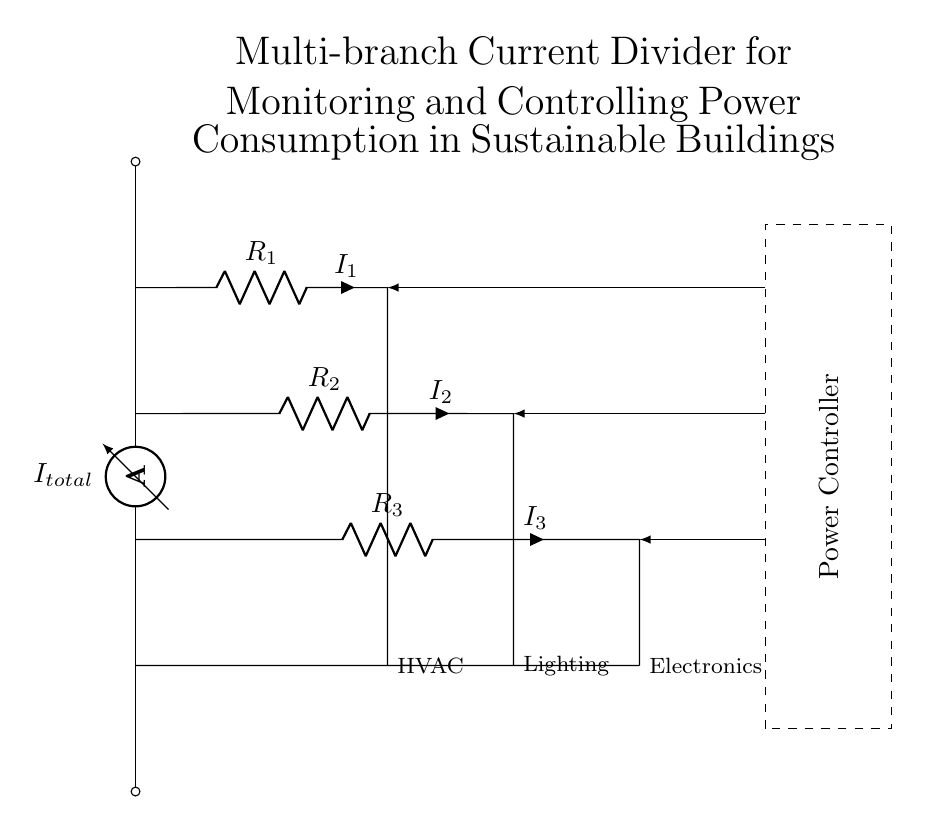What is the total current in the circuit? The total current is represented by the ammeter label, which is noted as I total in the circuit diagram.
Answer: I total How many branches are there in the current divider? By examining the diagram, we see three distinct branches: one for HVAC, one for lighting, and one for electronics.
Answer: Three What is the resistance value of the HVAC branch? The resistance for the HVAC branch is indicated as R sub 1 in the circuit diagram.
Answer: R sub 1 If R two is 10 ohms and R three is 20 ohms, what is the current through R two? This requires applying the current divider rule: I two equals I total times the resistance of R three divided by the sum of resistances (R two plus R three). Given the relationship, we can determine that the current through R two is directly proportional to its resistance.
Answer: I two Which component controls the overall power in the circuit? The component that serves this function is labeled as the Power Controller, which is encased in a dashed rectangle on the circuit diagram.
Answer: Power Controller What happens to the current if one branch is removed? Removing a branch would change the total resistance of the circuit, leading to alterations in the current distribution according to the current divider principle. All other branch currents would adjust based on the new total resistance.
Answer: Changes the current distribution What does the notation "I three" signify? The notation "I sub three" specifically represents the current flowing through the electronics branch of the current divider circuit.
Answer: Current through Electronics 